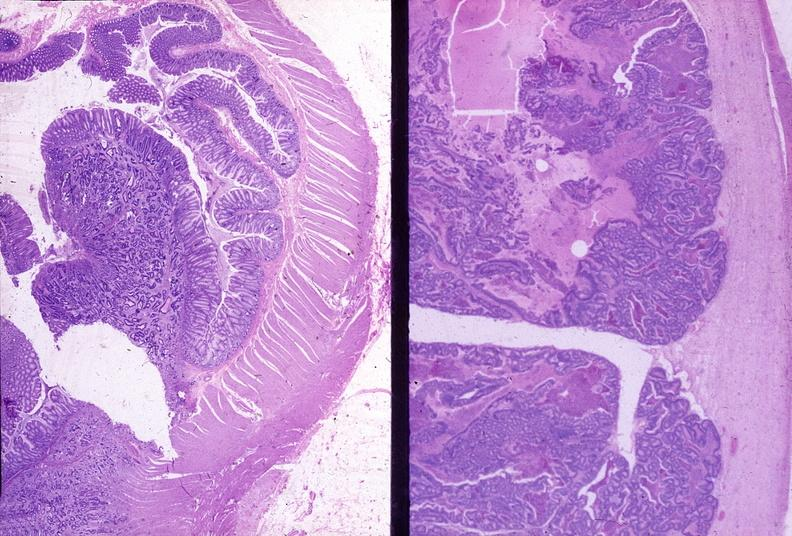where is this from?
Answer the question using a single word or phrase. Gastrointestinal system 